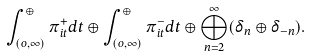Convert formula to latex. <formula><loc_0><loc_0><loc_500><loc_500>\int ^ { \oplus } _ { ( o , \infty ) } \pi _ { i t } ^ { + } d t \oplus \int ^ { \oplus } _ { ( o , \infty ) } \pi _ { i t } ^ { - } d t \oplus \bigoplus _ { n = 2 } ^ { \infty } ( \delta _ { n } \oplus \delta _ { - n } ) .</formula> 